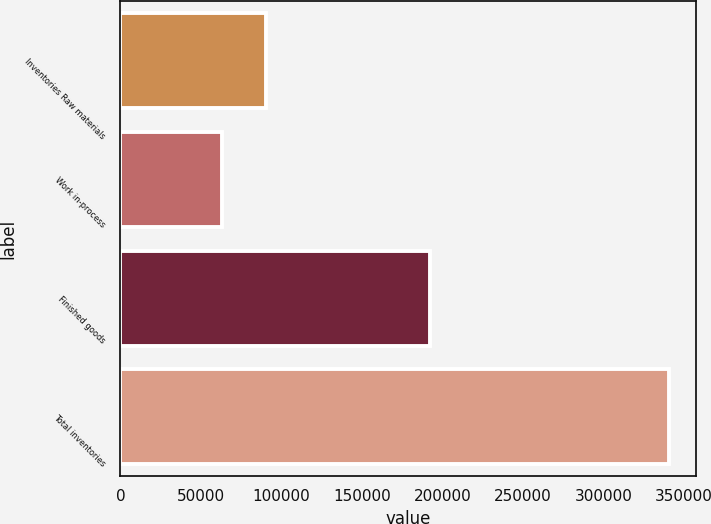<chart> <loc_0><loc_0><loc_500><loc_500><bar_chart><fcel>Inventories Raw materials<fcel>Work in-process<fcel>Finished goods<fcel>Total inventories<nl><fcel>90670.3<fcel>62934<fcel>192436<fcel>340297<nl></chart> 